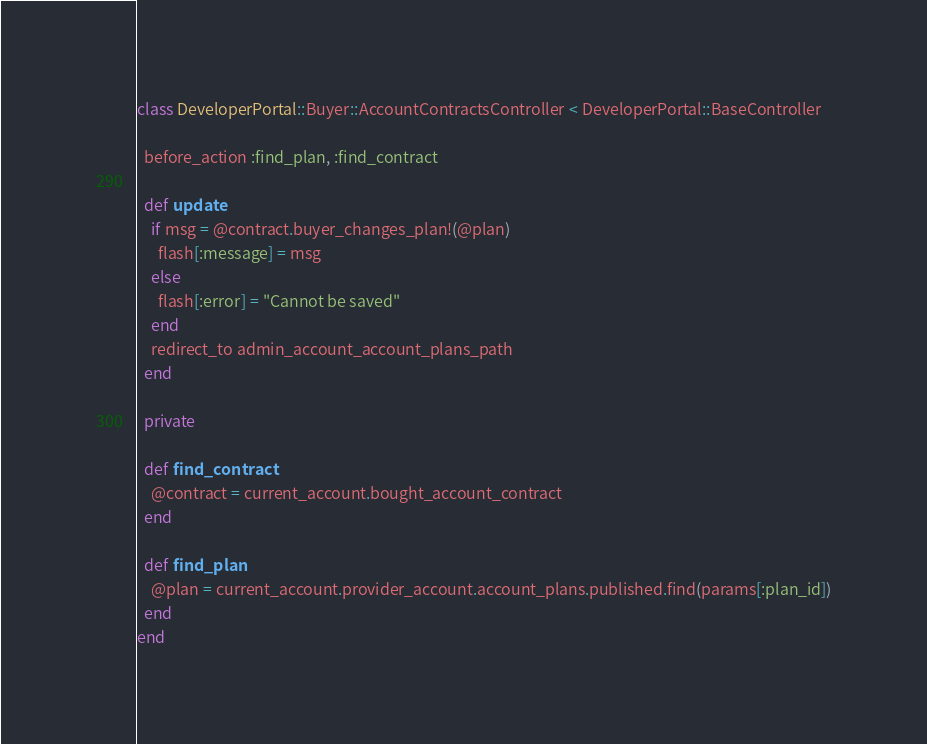<code> <loc_0><loc_0><loc_500><loc_500><_Ruby_>class DeveloperPortal::Buyer::AccountContractsController < DeveloperPortal::BaseController

  before_action :find_plan, :find_contract

  def update
    if msg = @contract.buyer_changes_plan!(@plan)
      flash[:message] = msg
    else
      flash[:error] = "Cannot be saved"
    end
    redirect_to admin_account_account_plans_path
  end

  private

  def find_contract
    @contract = current_account.bought_account_contract
  end

  def find_plan
    @plan = current_account.provider_account.account_plans.published.find(params[:plan_id])
  end
end
</code> 